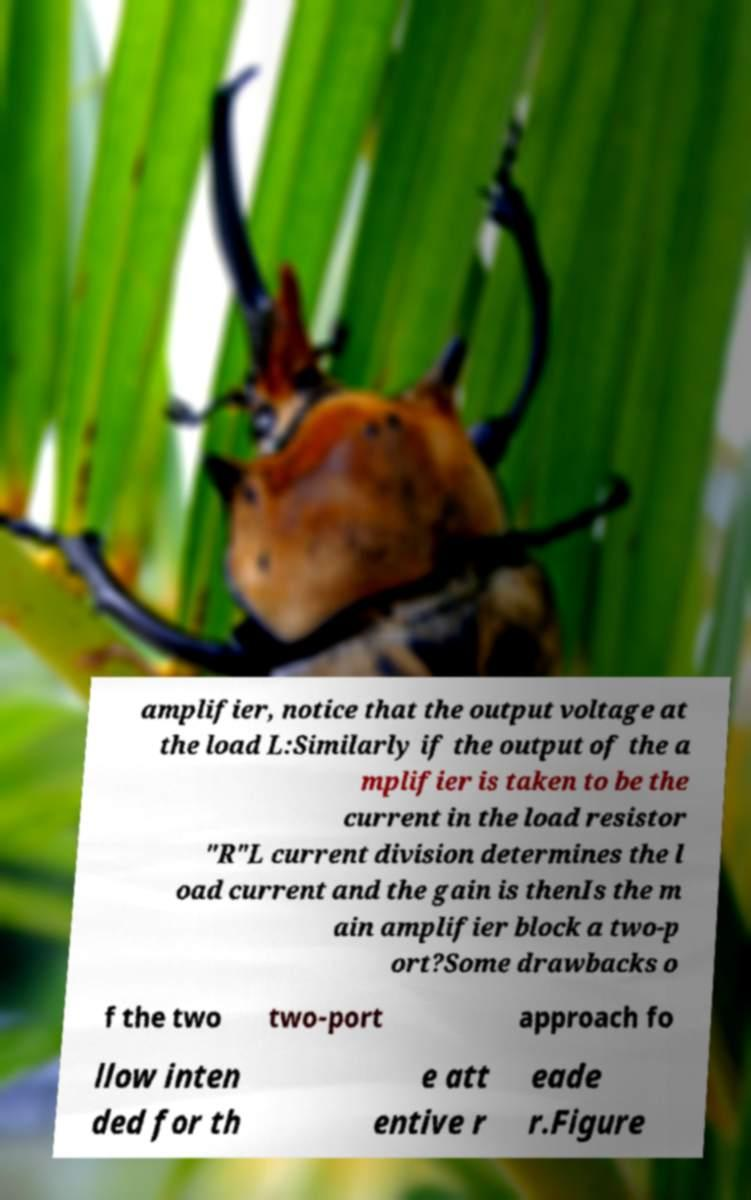Could you assist in decoding the text presented in this image and type it out clearly? amplifier, notice that the output voltage at the load L:Similarly if the output of the a mplifier is taken to be the current in the load resistor "R"L current division determines the l oad current and the gain is thenIs the m ain amplifier block a two-p ort?Some drawbacks o f the two two-port approach fo llow inten ded for th e att entive r eade r.Figure 